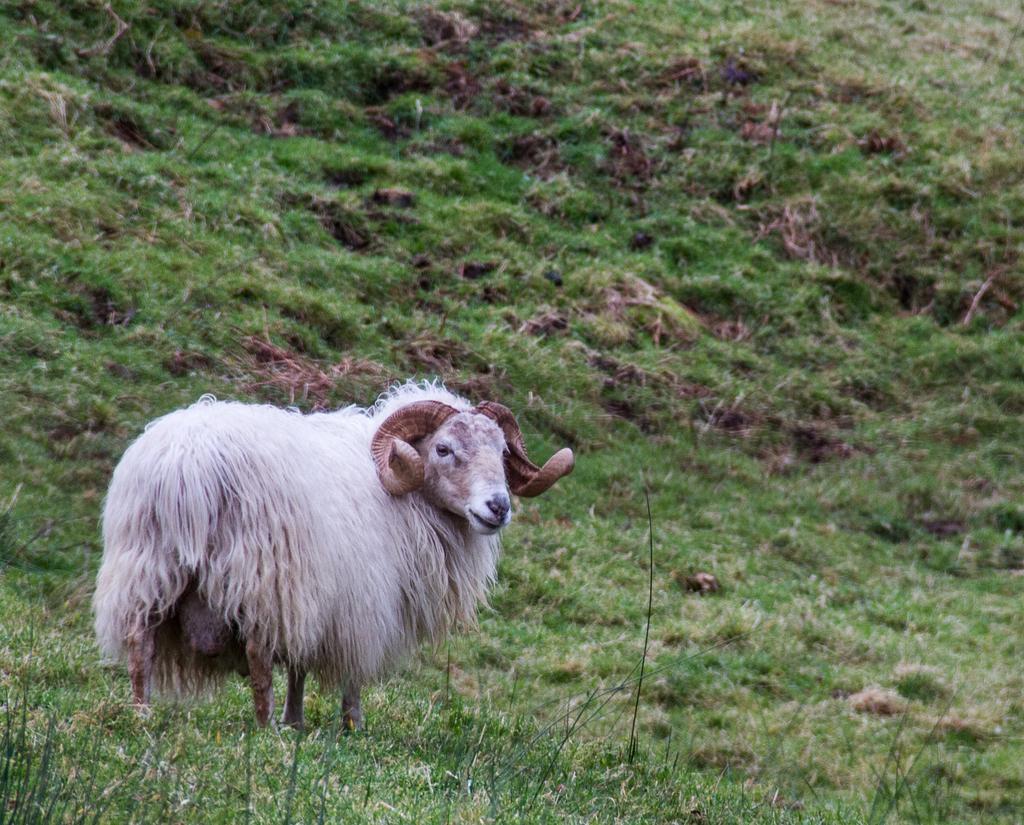Could you give a brief overview of what you see in this image? In this image I can see an animal which is in white and brown color. It is on the ground. In the background I can see the grass. 